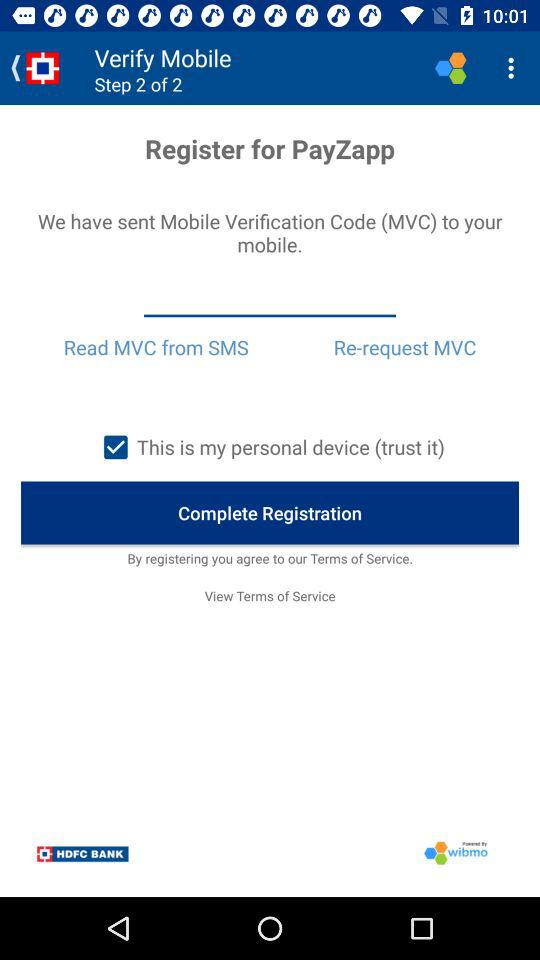Which verification step am I at? You are at verification step 2. 